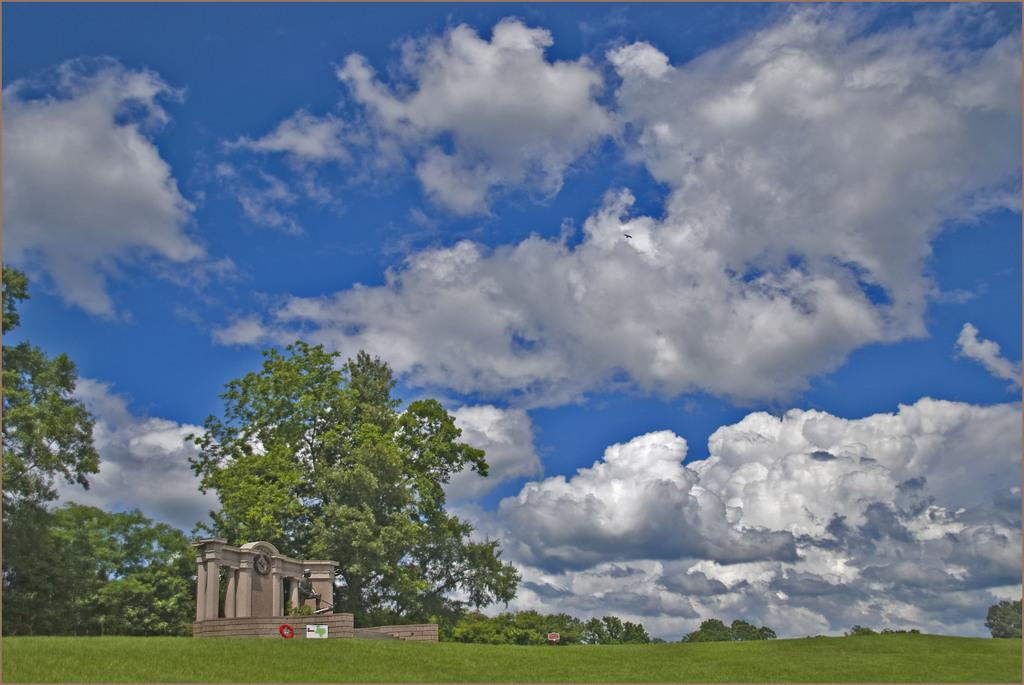What type of vegetation is present in the image? There are trees in the image. What is on the ground in the image? There is grass on the ground in the image. What type of structure can be seen in the image? There is a monument in the image. How would you describe the sky in the image? The sky is blue and cloudy in the image. Can you see any waves in the image? There are no waves present in the image. What month is it in the image? The month cannot be determined from the image, as it does not provide any information about the time of year. 